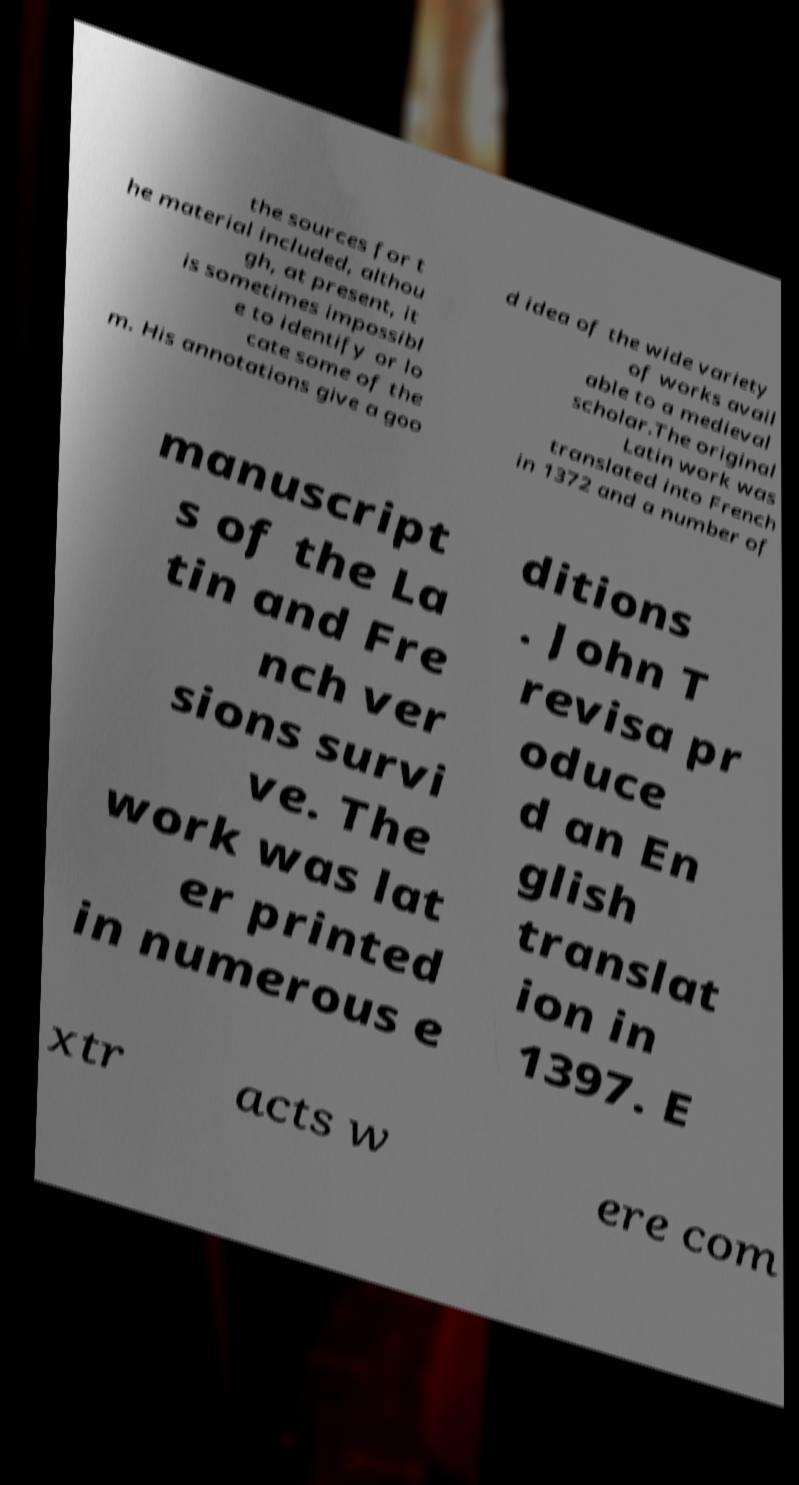Can you accurately transcribe the text from the provided image for me? the sources for t he material included, althou gh, at present, it is sometimes impossibl e to identify or lo cate some of the m. His annotations give a goo d idea of the wide variety of works avail able to a medieval scholar.The original Latin work was translated into French in 1372 and a number of manuscript s of the La tin and Fre nch ver sions survi ve. The work was lat er printed in numerous e ditions . John T revisa pr oduce d an En glish translat ion in 1397. E xtr acts w ere com 